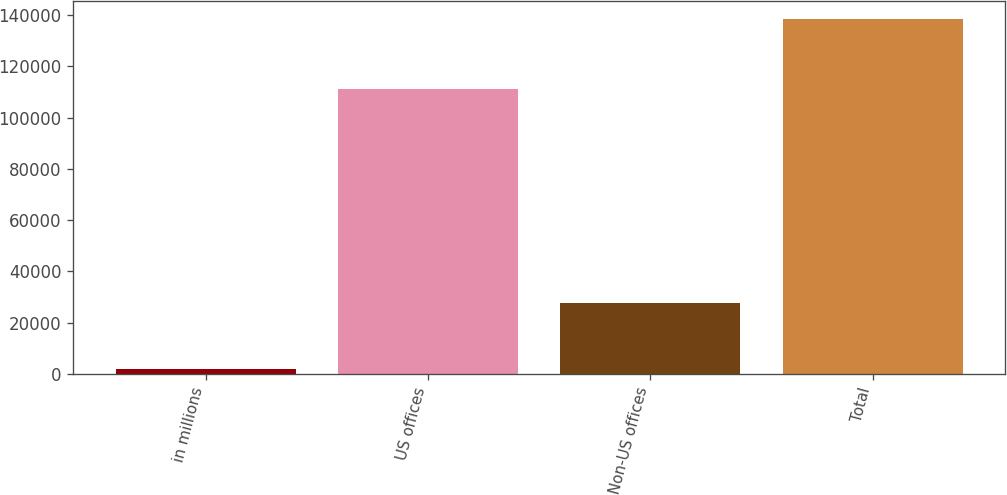<chart> <loc_0><loc_0><loc_500><loc_500><bar_chart><fcel>in millions<fcel>US offices<fcel>Non-US offices<fcel>Total<nl><fcel>2017<fcel>111002<fcel>27602<fcel>138604<nl></chart> 